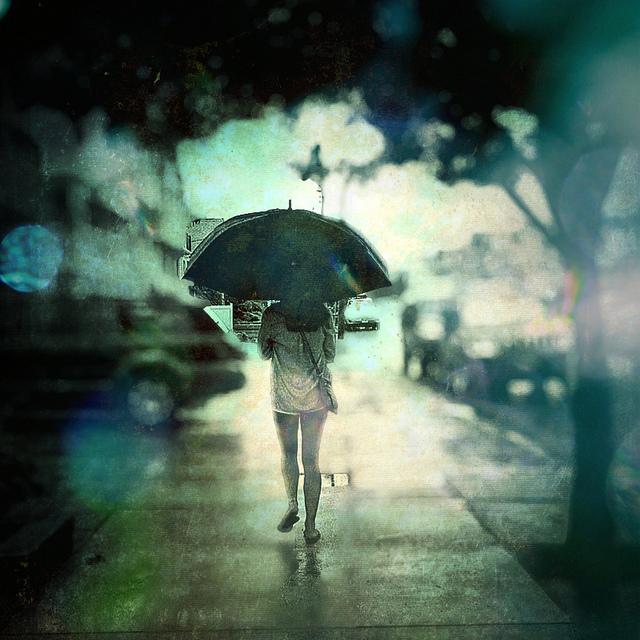Is the umbrella open?
Concise answer only. Yes. Is the camera lens wet?
Keep it brief. Yes. What is the weather like?
Be succinct. Rainy. 